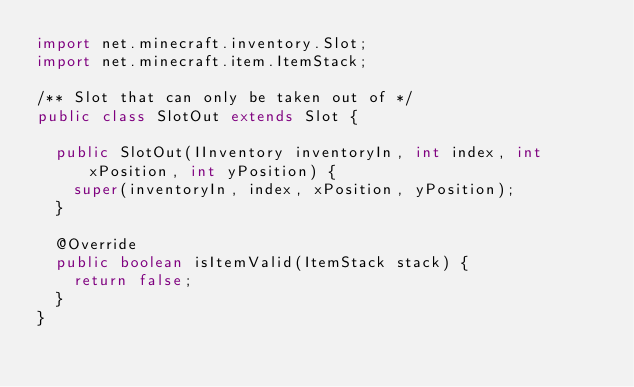Convert code to text. <code><loc_0><loc_0><loc_500><loc_500><_Java_>import net.minecraft.inventory.Slot;
import net.minecraft.item.ItemStack;

/** Slot that can only be taken out of */
public class SlotOut extends Slot {

  public SlotOut(IInventory inventoryIn, int index, int xPosition, int yPosition) {
    super(inventoryIn, index, xPosition, yPosition);
  }

  @Override
  public boolean isItemValid(ItemStack stack) {
    return false;
  }
}
</code> 